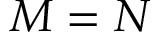<formula> <loc_0><loc_0><loc_500><loc_500>M = N</formula> 